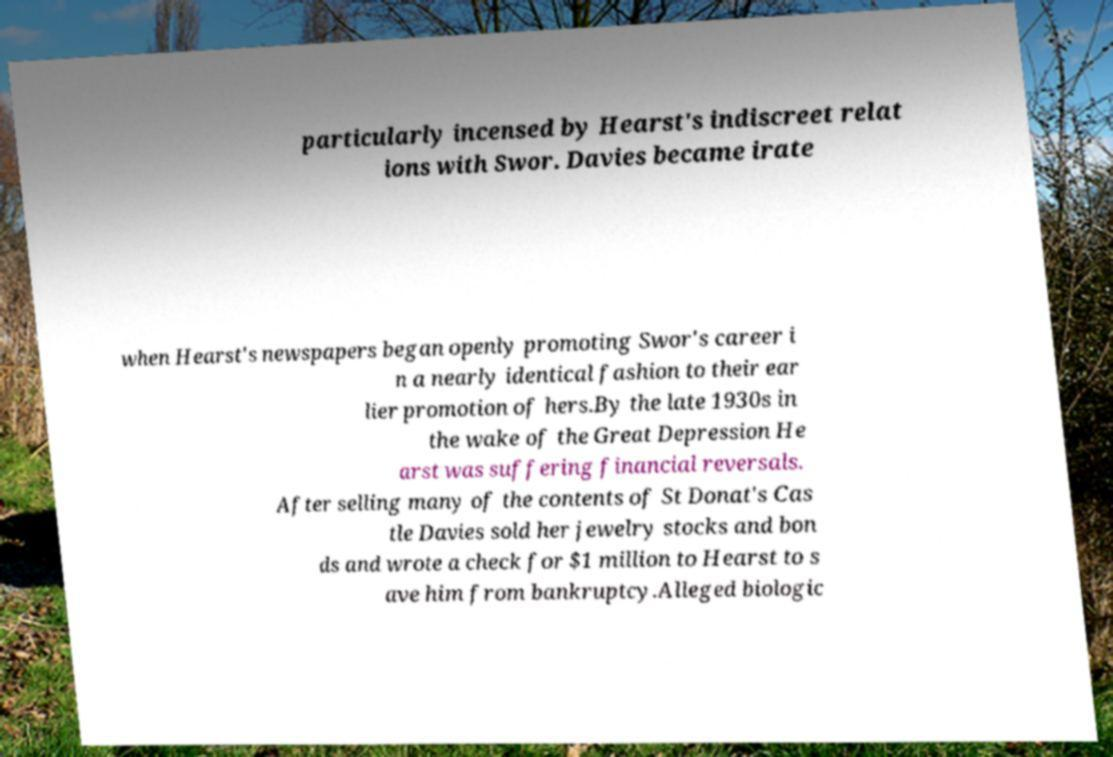For documentation purposes, I need the text within this image transcribed. Could you provide that? particularly incensed by Hearst's indiscreet relat ions with Swor. Davies became irate when Hearst's newspapers began openly promoting Swor's career i n a nearly identical fashion to their ear lier promotion of hers.By the late 1930s in the wake of the Great Depression He arst was suffering financial reversals. After selling many of the contents of St Donat's Cas tle Davies sold her jewelry stocks and bon ds and wrote a check for $1 million to Hearst to s ave him from bankruptcy.Alleged biologic 